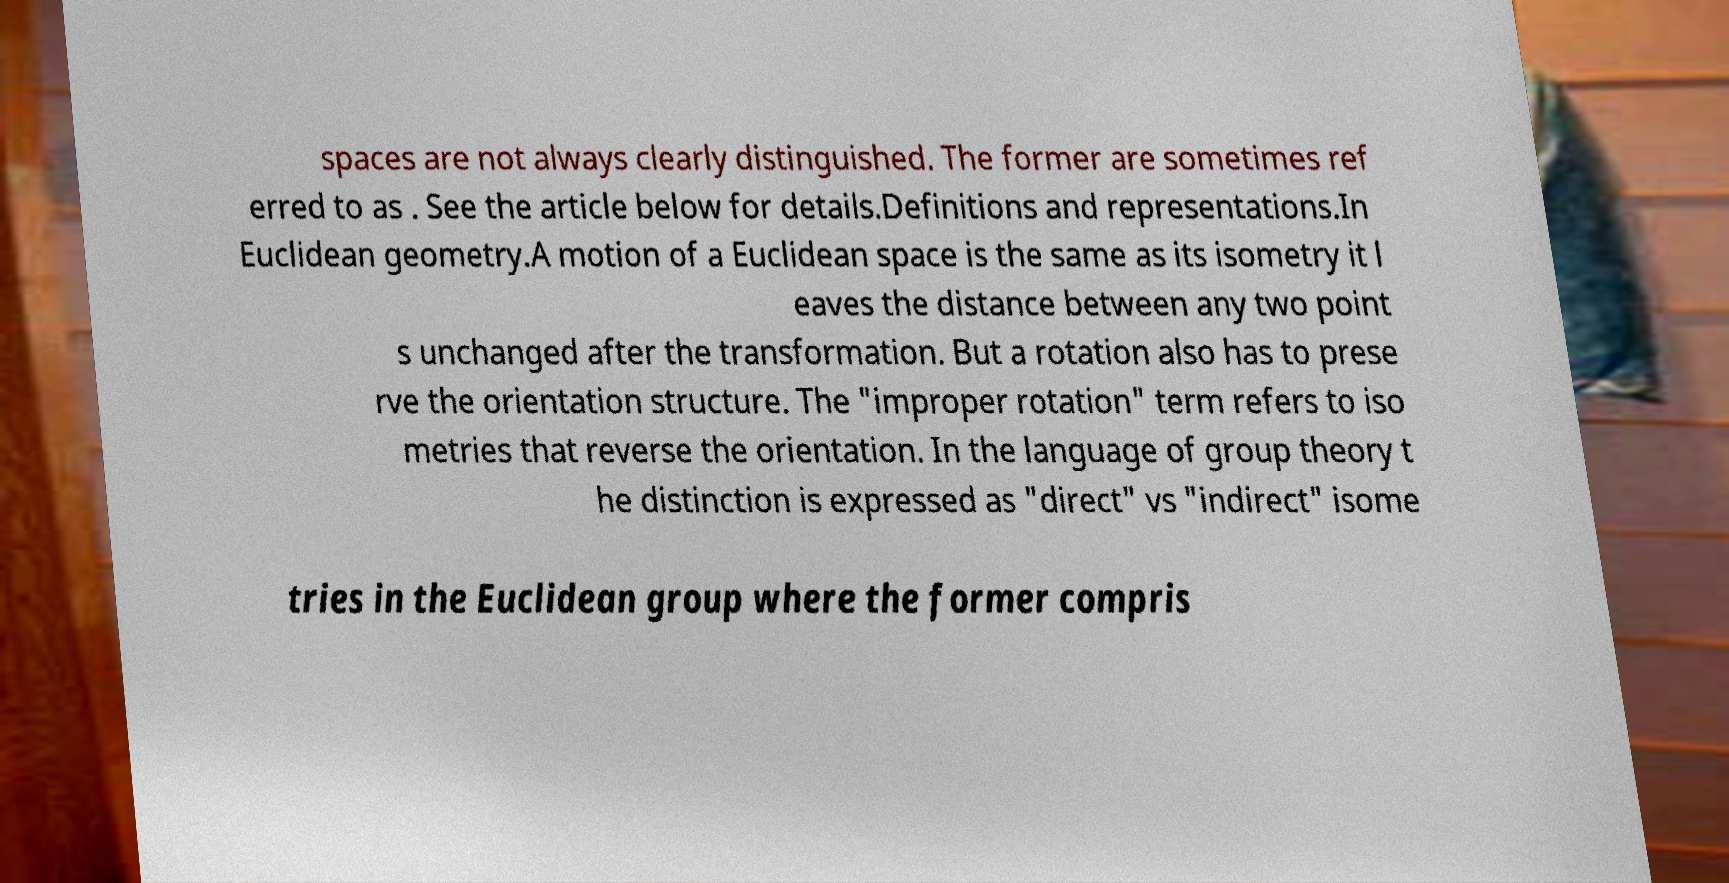Could you extract and type out the text from this image? spaces are not always clearly distinguished. The former are sometimes ref erred to as . See the article below for details.Definitions and representations.In Euclidean geometry.A motion of a Euclidean space is the same as its isometry it l eaves the distance between any two point s unchanged after the transformation. But a rotation also has to prese rve the orientation structure. The "improper rotation" term refers to iso metries that reverse the orientation. In the language of group theory t he distinction is expressed as "direct" vs "indirect" isome tries in the Euclidean group where the former compris 